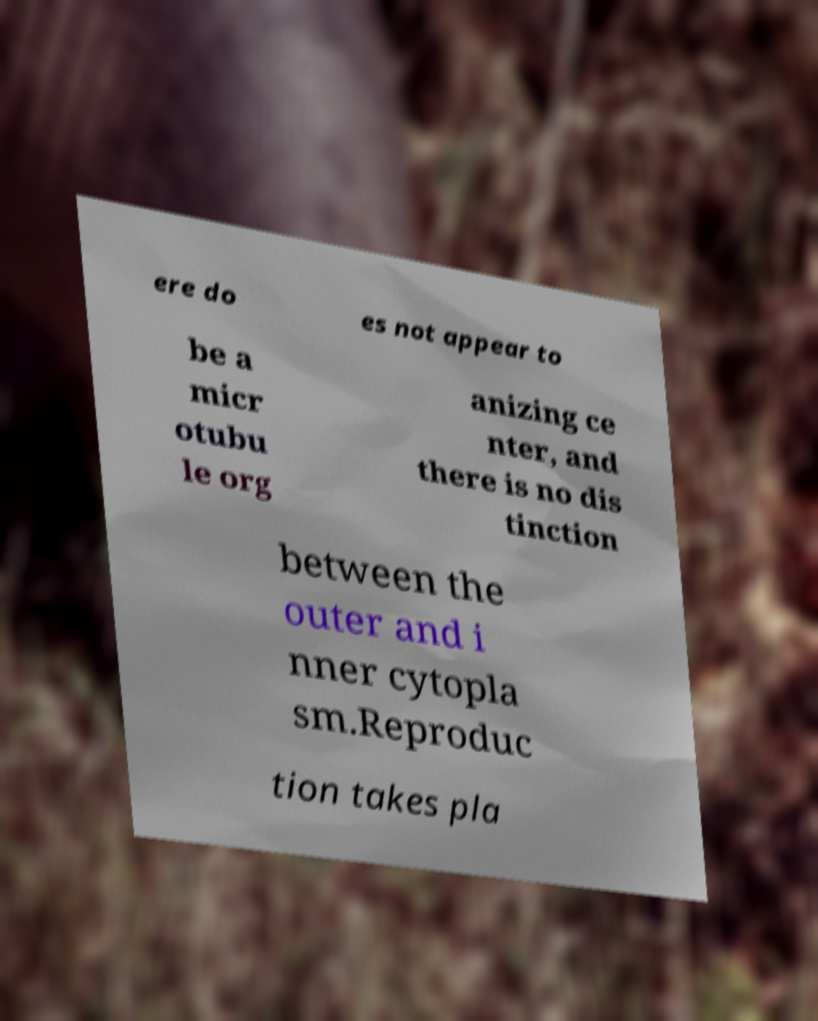Please identify and transcribe the text found in this image. ere do es not appear to be a micr otubu le org anizing ce nter, and there is no dis tinction between the outer and i nner cytopla sm.Reproduc tion takes pla 